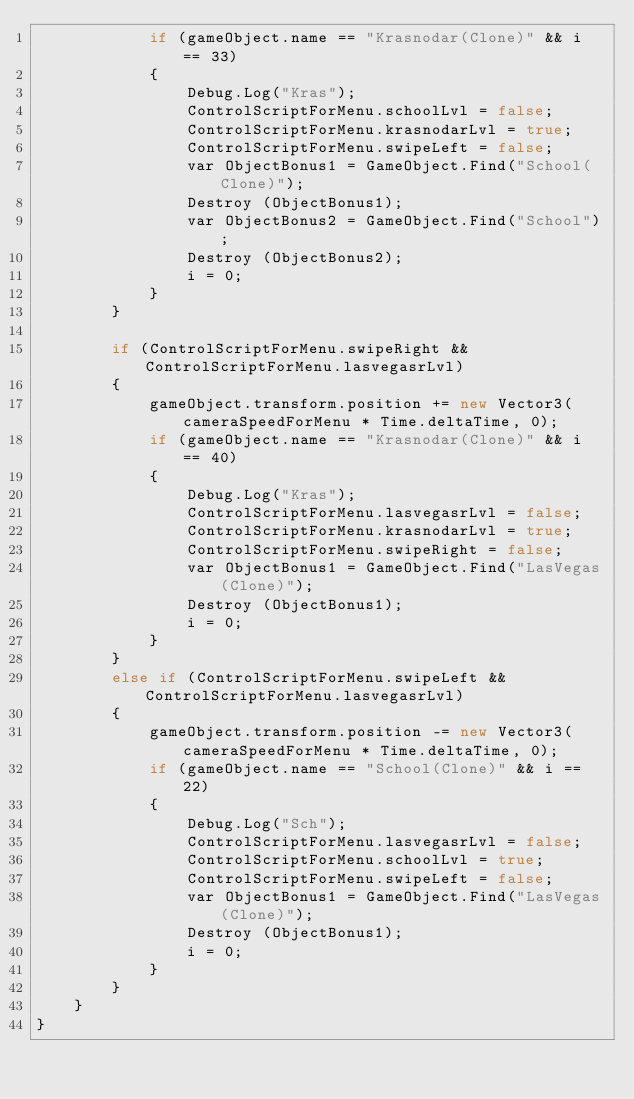<code> <loc_0><loc_0><loc_500><loc_500><_C#_>            if (gameObject.name == "Krasnodar(Clone)" && i == 33)
            {
                Debug.Log("Kras");
                ControlScriptForMenu.schoolLvl = false;
                ControlScriptForMenu.krasnodarLvl = true;
                ControlScriptForMenu.swipeLeft = false;
                var ObjectBonus1 = GameObject.Find("School(Clone)");
                Destroy (ObjectBonus1);
                var ObjectBonus2 = GameObject.Find("School");
                Destroy (ObjectBonus2);
                i = 0;
            }
        }
        
        if (ControlScriptForMenu.swipeRight && ControlScriptForMenu.lasvegasrLvl)
        {
            gameObject.transform.position += new Vector3(cameraSpeedForMenu * Time.deltaTime, 0);
            if (gameObject.name == "Krasnodar(Clone)" && i == 40)
            {
                Debug.Log("Kras");
                ControlScriptForMenu.lasvegasrLvl = false;
                ControlScriptForMenu.krasnodarLvl = true;
                ControlScriptForMenu.swipeRight = false;
                var ObjectBonus1 = GameObject.Find("LasVegas(Clone)");
                Destroy (ObjectBonus1);
                i = 0;
            }
        }
        else if (ControlScriptForMenu.swipeLeft && ControlScriptForMenu.lasvegasrLvl)
        {
            gameObject.transform.position -= new Vector3(cameraSpeedForMenu * Time.deltaTime, 0);
            if (gameObject.name == "School(Clone)" && i == 22)
            {
                Debug.Log("Sch");
                ControlScriptForMenu.lasvegasrLvl = false;
                ControlScriptForMenu.schoolLvl = true;
                ControlScriptForMenu.swipeLeft = false;
                var ObjectBonus1 = GameObject.Find("LasVegas(Clone)");
                Destroy (ObjectBonus1);
                i = 0;
            }
        }
    }
}
</code> 